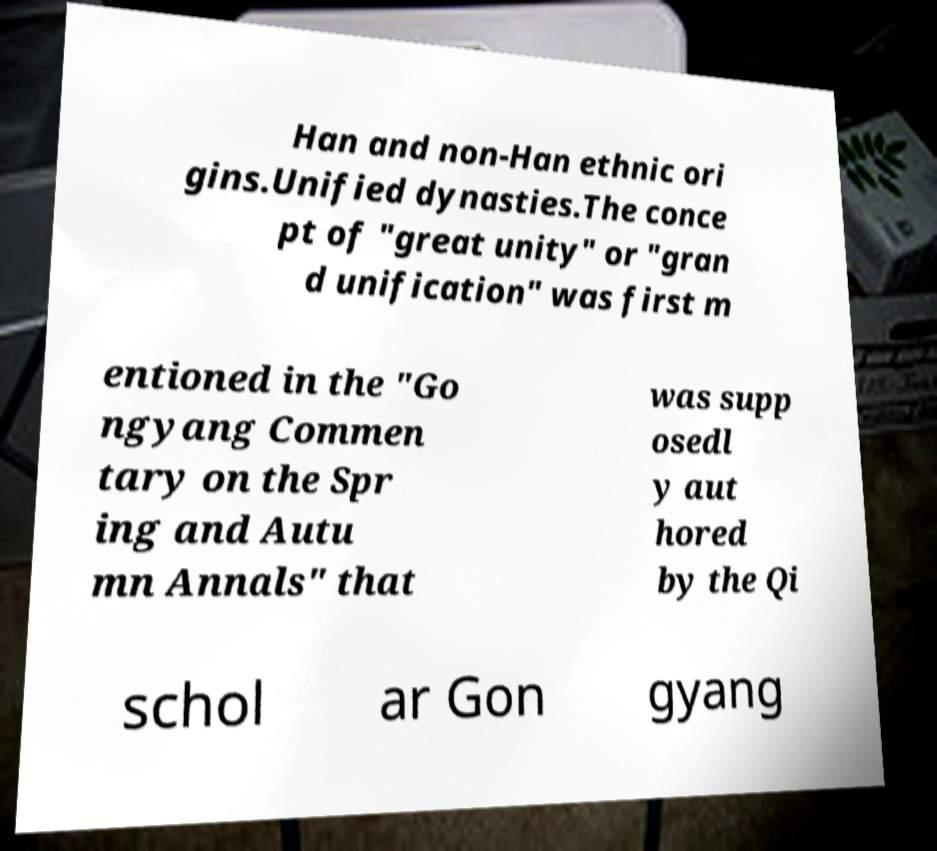Could you extract and type out the text from this image? Han and non-Han ethnic ori gins.Unified dynasties.The conce pt of "great unity" or "gran d unification" was first m entioned in the "Go ngyang Commen tary on the Spr ing and Autu mn Annals" that was supp osedl y aut hored by the Qi schol ar Gon gyang 